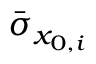Convert formula to latex. <formula><loc_0><loc_0><loc_500><loc_500>\bar { \sigma } _ { x _ { 0 , i } }</formula> 